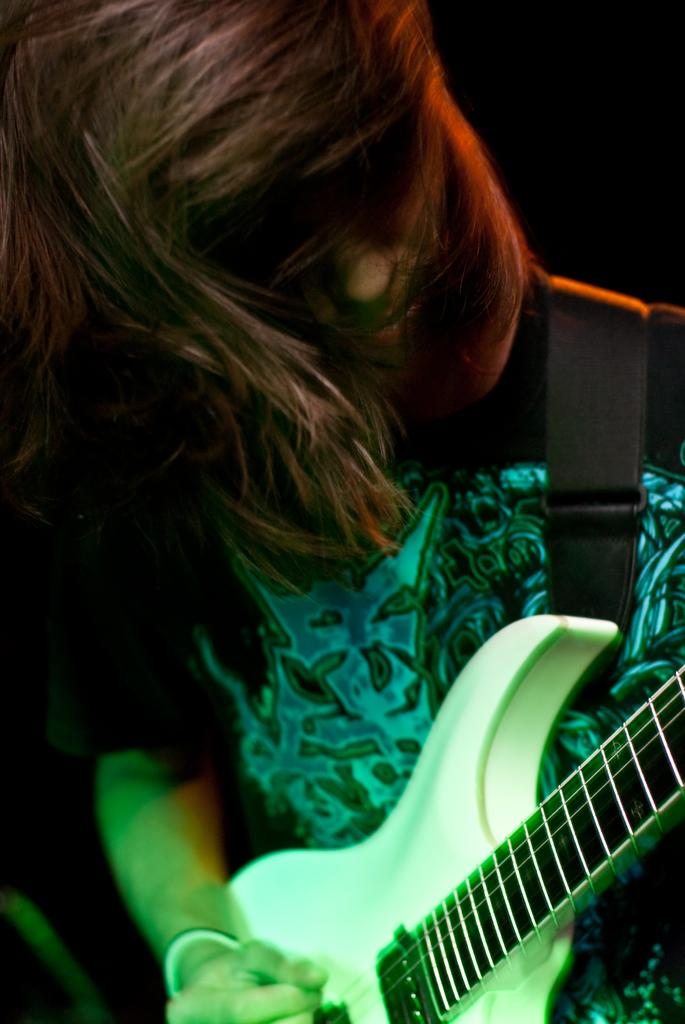Who is the main subject in the image? There is a girl in the image. What is the girl doing in the image? The girl is standing and playing the guitar. How is the girl playing the guitar? The girl is using her hands to play the guitar. What is the girl wearing in the image? The girl is wearing a black and blue color dress. What is the description of the girl's dress? The dress is described as "very good." What type of zinc is present in the image? There is no zinc present in the image. Is the girl using a pencil to play the guitar in the image? No, the girl is using her hands to play the guitar in the image. 